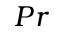<formula> <loc_0><loc_0><loc_500><loc_500>P r</formula> 